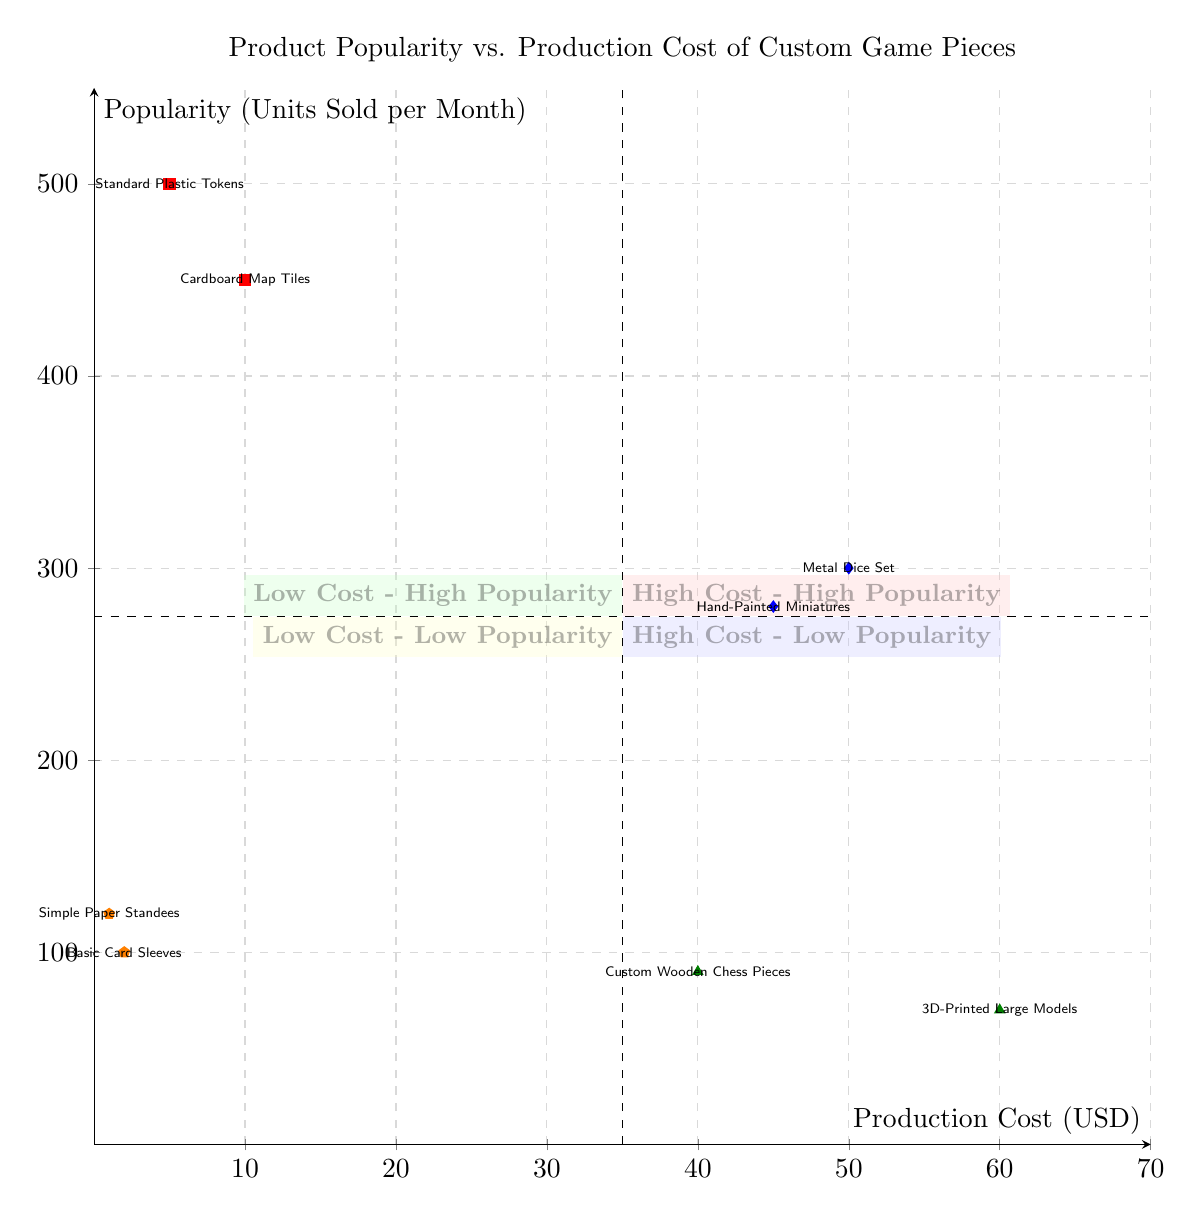What is the production cost of the Metal Dice Set? The diagram shows the position of the Metal Dice Set in the "High Cost - High Popularity" quadrant. Based on the data for this product, its production cost is listed as 50 USD.
Answer: 50 How many units of Standard Plastic Tokens are sold per month? The Standard Plastic Tokens are positioned in the "Low Cost - High Popularity" quadrant. The data for this product states that it has a popularity of 500 units sold per month.
Answer: 500 Which product has the highest popularity? To determine this, we need to compare the popularity values listed for all products. The product with the highest popularity is the Standard Plastic Tokens, with 500 units sold per month.
Answer: Standard Plastic Tokens How many products are in the High Cost - Low Popularity quadrant? The High Cost - Low Popularity quadrant includes two products: Custom Wooden Chess Pieces and 3D-Printed Large Models. Thus, the total count of products in this quadrant is two.
Answer: 2 What is the total production cost of all products in the Low Cost - High Popularity quadrant? The Low Cost - High Popularity quadrant consists of Standard Plastic Tokens (5 USD) and Cardboard Map Tiles (10 USD). Adding these values gives a total production cost of 15 USD.
Answer: 15 Which quadrant has products with a production cost less than 10 USD? According to the diagram, the Low Cost - High Popularity quadrant contains products with production costs of 5 USD and 10 USD. Therefore, it is this quadrant that has products with a production cost less than 10 USD.
Answer: Low Cost - High Popularity How many products are classified as High Cost - High Popularity? The High Cost - High Popularity quadrant lists two products: Metal Dice Set and Hand-Painted Miniatures. Therefore, the total number of products in this category is two.
Answer: 2 What is the popularity of the Custom Wooden Chess Pieces? In the "High Cost - Low Popularity" quadrant, the data for Custom Wooden Chess Pieces indicates a popularity of 90 units sold per month.
Answer: 90 Which is more costly, the Basic Card Sleeves or the Simple Paper Standees? The Basic Card Sleeves have a production cost of 2 USD and the Simple Paper Standees have a cost of 1 USD. Comparing these costs shows that the Basic Card Sleeves are more costly.
Answer: Basic Card Sleeves 